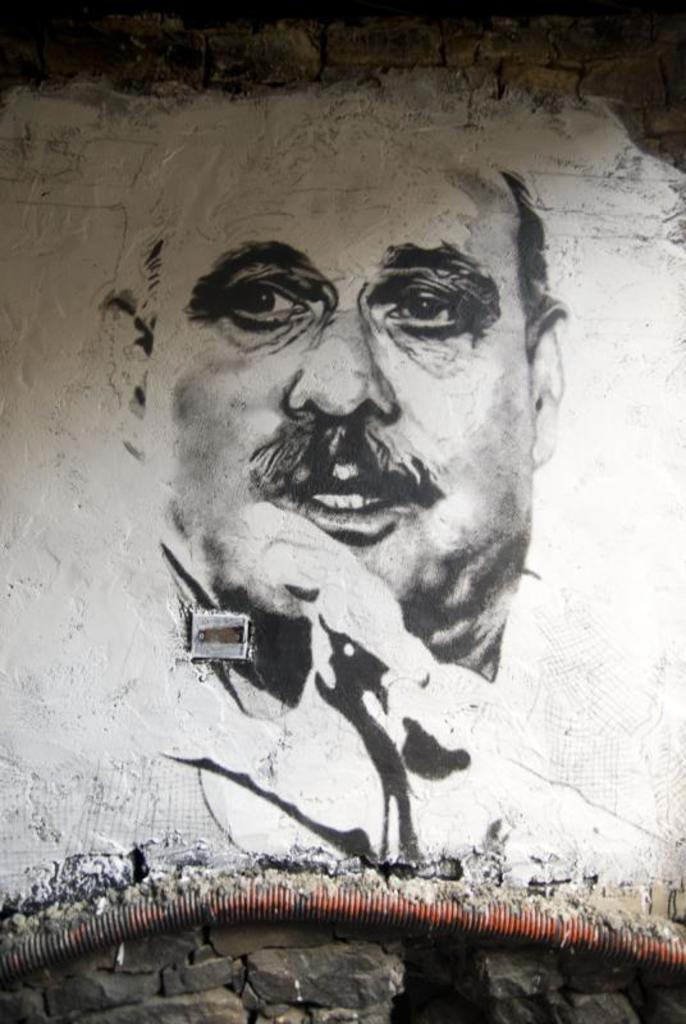In one or two sentences, can you explain what this image depicts? In this picture there is a sketch on a wall in the center of the image and there is a pipe at the bottom side of the image. 